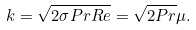Convert formula to latex. <formula><loc_0><loc_0><loc_500><loc_500>k = \sqrt { 2 \sigma P r R e } = \sqrt { 2 P r } \mu .</formula> 